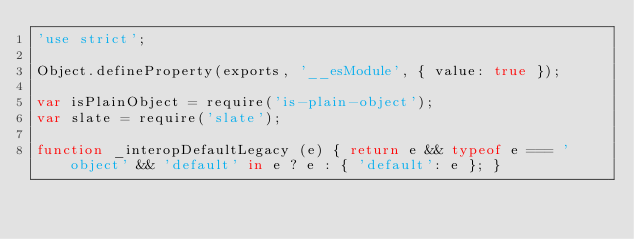Convert code to text. <code><loc_0><loc_0><loc_500><loc_500><_JavaScript_>'use strict';

Object.defineProperty(exports, '__esModule', { value: true });

var isPlainObject = require('is-plain-object');
var slate = require('slate');

function _interopDefaultLegacy (e) { return e && typeof e === 'object' && 'default' in e ? e : { 'default': e }; }
</code> 